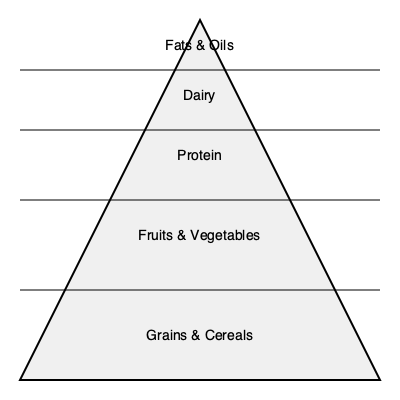As a nanny responsible for planning balanced meals for children, which food group should form the largest portion of a child's daily diet according to the food pyramid shown? To answer this question, let's analyze the food pyramid graphic step-by-step:

1. The food pyramid is divided into five sections, with the largest section at the bottom and the smallest at the top.

2. The sections, from bottom to top, represent:
   a. Grains & Cereals
   b. Fruits & Vegetables
   c. Protein
   d. Dairy
   e. Fats & Oils

3. In a food pyramid, the size of each section indicates the recommended proportion of that food group in a balanced diet.

4. The largest section at the bottom of the pyramid represents the food group that should form the largest portion of the diet.

5. In this pyramid, the largest section at the bottom is labeled "Grains & Cereals."

6. Therefore, according to this food pyramid, grains and cereals should form the largest portion of a child's daily diet.

7. As a nanny, it's important to ensure that children receive a variety of foods from all groups, but with an emphasis on whole grains and cereals as the foundation of their meals.
Answer: Grains & Cereals 